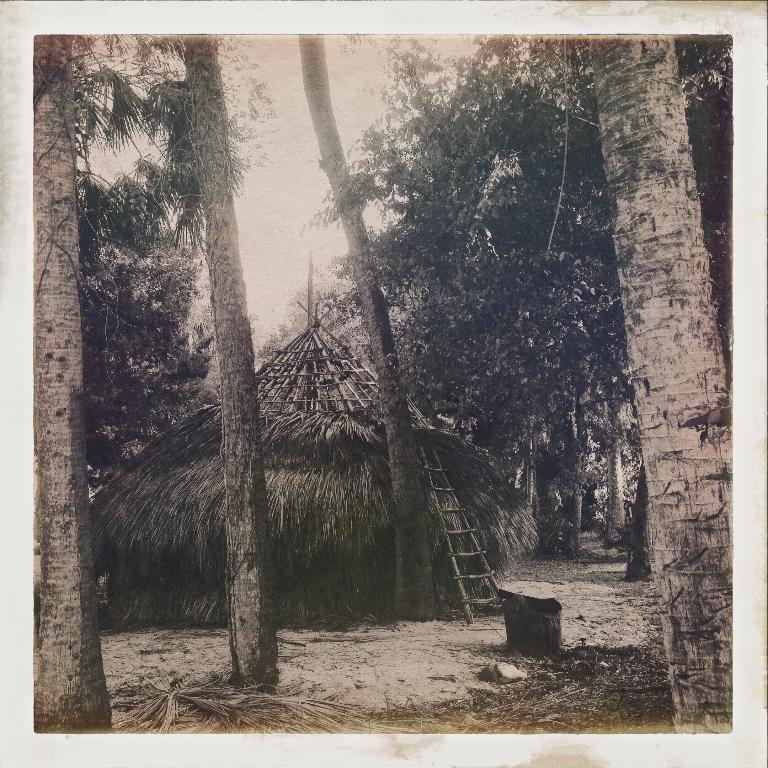Could you give a brief overview of what you see in this image? This is a black and white picture, there are few coconut trees in the front and behind there is a hut with a ladder in front of it. 